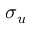<formula> <loc_0><loc_0><loc_500><loc_500>\sigma _ { u }</formula> 